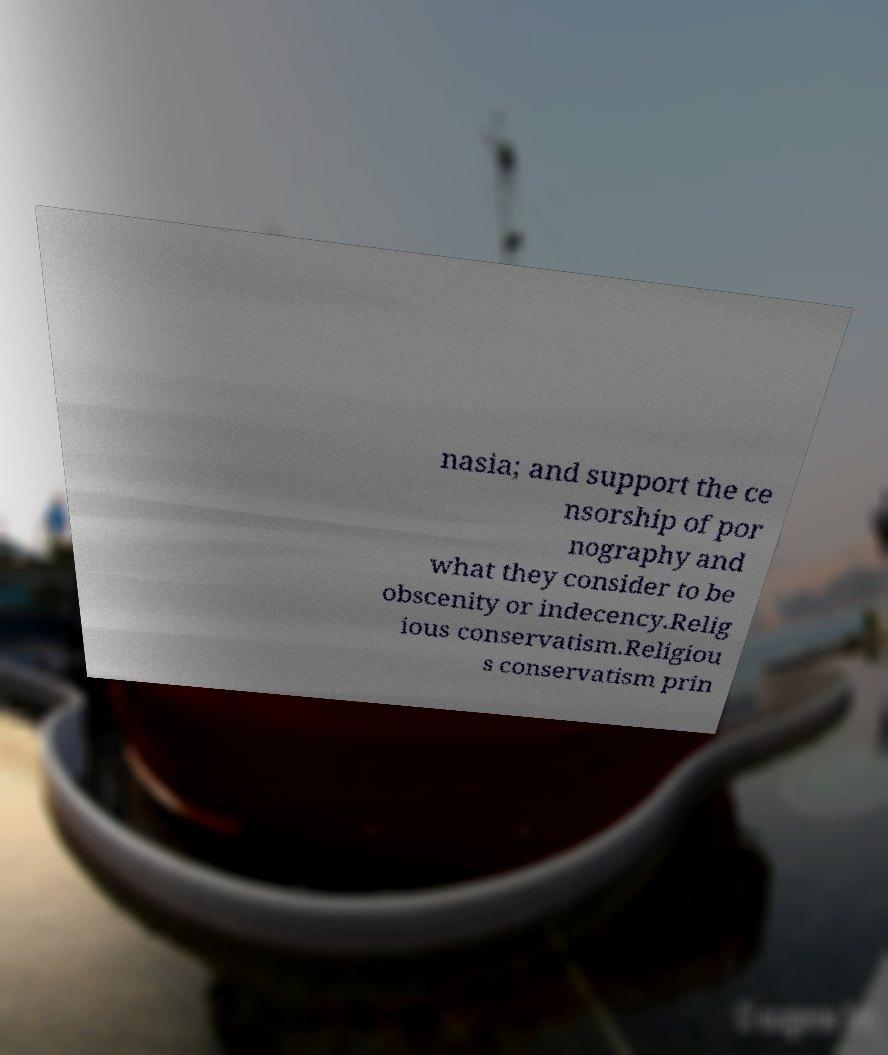There's text embedded in this image that I need extracted. Can you transcribe it verbatim? nasia; and support the ce nsorship of por nography and what they consider to be obscenity or indecency.Relig ious conservatism.Religiou s conservatism prin 